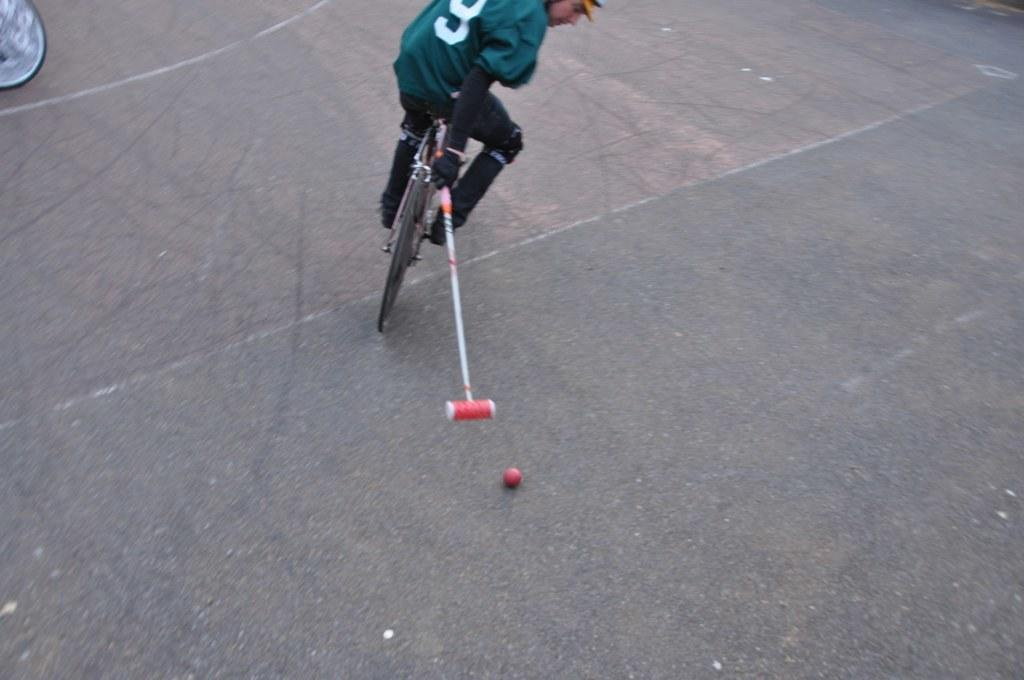What is the main subject of the image? There is a person in the image. What is the person wearing? The person is wearing clothes, shoes, and gloves. What activity is the person engaged in? The person is riding a bicycle. What object is the person holding? The person is holding an object. What else can be seen in the image? There is a ball and a road in the image. What type of government is depicted in the image? There is no depiction of a government in the image; it features a person riding a bicycle. How many rocks can be seen in the image? There are no rocks present in the image. 